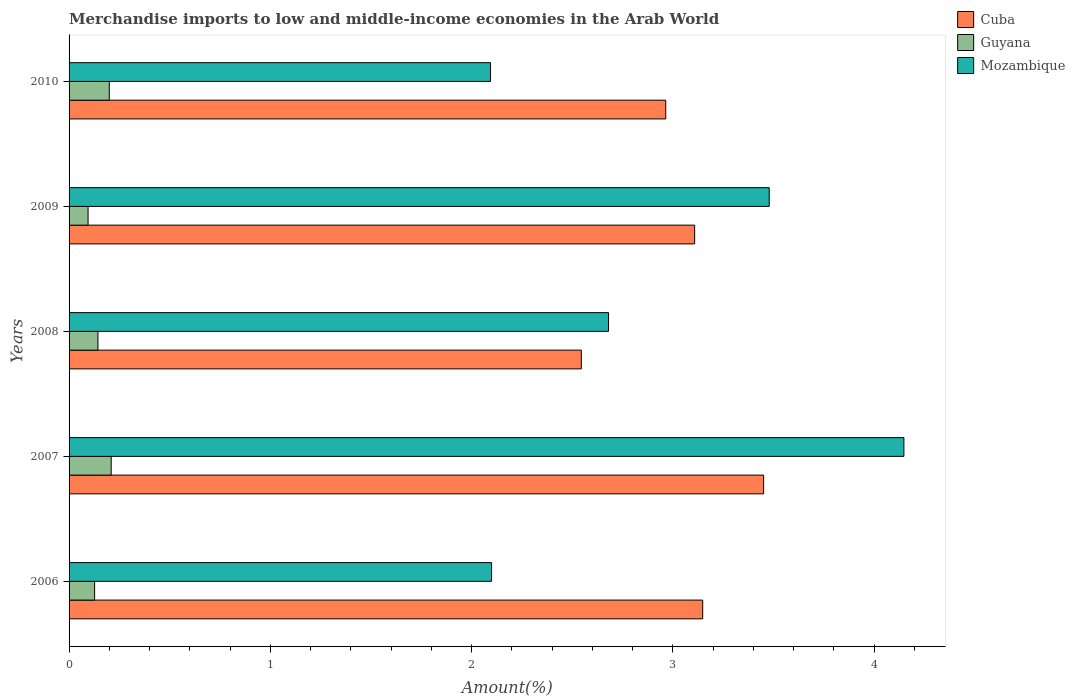How many groups of bars are there?
Provide a short and direct response. 5. Are the number of bars per tick equal to the number of legend labels?
Your response must be concise. Yes. In how many cases, is the number of bars for a given year not equal to the number of legend labels?
Provide a short and direct response. 0. What is the percentage of amount earned from merchandise imports in Cuba in 2009?
Give a very brief answer. 3.11. Across all years, what is the maximum percentage of amount earned from merchandise imports in Mozambique?
Your answer should be compact. 4.15. Across all years, what is the minimum percentage of amount earned from merchandise imports in Guyana?
Your response must be concise. 0.09. In which year was the percentage of amount earned from merchandise imports in Guyana maximum?
Your response must be concise. 2007. What is the total percentage of amount earned from merchandise imports in Cuba in the graph?
Your answer should be compact. 15.22. What is the difference between the percentage of amount earned from merchandise imports in Cuba in 2006 and that in 2008?
Your response must be concise. 0.6. What is the difference between the percentage of amount earned from merchandise imports in Guyana in 2008 and the percentage of amount earned from merchandise imports in Cuba in 2007?
Your answer should be compact. -3.31. What is the average percentage of amount earned from merchandise imports in Cuba per year?
Give a very brief answer. 3.04. In the year 2006, what is the difference between the percentage of amount earned from merchandise imports in Mozambique and percentage of amount earned from merchandise imports in Guyana?
Provide a short and direct response. 1.97. In how many years, is the percentage of amount earned from merchandise imports in Guyana greater than 2.6 %?
Offer a terse response. 0. What is the ratio of the percentage of amount earned from merchandise imports in Mozambique in 2009 to that in 2010?
Offer a terse response. 1.66. Is the percentage of amount earned from merchandise imports in Cuba in 2006 less than that in 2009?
Offer a very short reply. No. What is the difference between the highest and the second highest percentage of amount earned from merchandise imports in Guyana?
Keep it short and to the point. 0.01. What is the difference between the highest and the lowest percentage of amount earned from merchandise imports in Cuba?
Provide a short and direct response. 0.91. In how many years, is the percentage of amount earned from merchandise imports in Guyana greater than the average percentage of amount earned from merchandise imports in Guyana taken over all years?
Provide a succinct answer. 2. Is the sum of the percentage of amount earned from merchandise imports in Mozambique in 2007 and 2009 greater than the maximum percentage of amount earned from merchandise imports in Guyana across all years?
Your response must be concise. Yes. What does the 2nd bar from the top in 2007 represents?
Keep it short and to the point. Guyana. What does the 2nd bar from the bottom in 2010 represents?
Offer a very short reply. Guyana. How many bars are there?
Provide a succinct answer. 15. Are the values on the major ticks of X-axis written in scientific E-notation?
Provide a short and direct response. No. Does the graph contain grids?
Offer a terse response. No. Where does the legend appear in the graph?
Provide a succinct answer. Top right. How many legend labels are there?
Ensure brevity in your answer.  3. How are the legend labels stacked?
Provide a succinct answer. Vertical. What is the title of the graph?
Offer a very short reply. Merchandise imports to low and middle-income economies in the Arab World. What is the label or title of the X-axis?
Make the answer very short. Amount(%). What is the label or title of the Y-axis?
Offer a very short reply. Years. What is the Amount(%) in Cuba in 2006?
Offer a terse response. 3.15. What is the Amount(%) in Guyana in 2006?
Provide a succinct answer. 0.13. What is the Amount(%) of Mozambique in 2006?
Your answer should be compact. 2.1. What is the Amount(%) of Cuba in 2007?
Your response must be concise. 3.45. What is the Amount(%) of Guyana in 2007?
Offer a terse response. 0.21. What is the Amount(%) of Mozambique in 2007?
Offer a terse response. 4.15. What is the Amount(%) of Cuba in 2008?
Keep it short and to the point. 2.55. What is the Amount(%) of Guyana in 2008?
Provide a short and direct response. 0.14. What is the Amount(%) in Mozambique in 2008?
Your answer should be very brief. 2.68. What is the Amount(%) in Cuba in 2009?
Your answer should be compact. 3.11. What is the Amount(%) in Guyana in 2009?
Provide a short and direct response. 0.09. What is the Amount(%) in Mozambique in 2009?
Your answer should be compact. 3.48. What is the Amount(%) of Cuba in 2010?
Offer a terse response. 2.96. What is the Amount(%) in Guyana in 2010?
Ensure brevity in your answer.  0.2. What is the Amount(%) of Mozambique in 2010?
Provide a succinct answer. 2.09. Across all years, what is the maximum Amount(%) in Cuba?
Offer a very short reply. 3.45. Across all years, what is the maximum Amount(%) of Guyana?
Offer a terse response. 0.21. Across all years, what is the maximum Amount(%) in Mozambique?
Keep it short and to the point. 4.15. Across all years, what is the minimum Amount(%) of Cuba?
Give a very brief answer. 2.55. Across all years, what is the minimum Amount(%) in Guyana?
Ensure brevity in your answer.  0.09. Across all years, what is the minimum Amount(%) of Mozambique?
Keep it short and to the point. 2.09. What is the total Amount(%) of Cuba in the graph?
Keep it short and to the point. 15.22. What is the total Amount(%) of Guyana in the graph?
Make the answer very short. 0.77. What is the total Amount(%) of Mozambique in the graph?
Keep it short and to the point. 14.5. What is the difference between the Amount(%) of Cuba in 2006 and that in 2007?
Your response must be concise. -0.3. What is the difference between the Amount(%) of Guyana in 2006 and that in 2007?
Keep it short and to the point. -0.08. What is the difference between the Amount(%) of Mozambique in 2006 and that in 2007?
Ensure brevity in your answer.  -2.05. What is the difference between the Amount(%) in Cuba in 2006 and that in 2008?
Provide a short and direct response. 0.6. What is the difference between the Amount(%) of Guyana in 2006 and that in 2008?
Your response must be concise. -0.02. What is the difference between the Amount(%) in Mozambique in 2006 and that in 2008?
Give a very brief answer. -0.58. What is the difference between the Amount(%) in Cuba in 2006 and that in 2009?
Your response must be concise. 0.04. What is the difference between the Amount(%) of Guyana in 2006 and that in 2009?
Your answer should be very brief. 0.03. What is the difference between the Amount(%) of Mozambique in 2006 and that in 2009?
Offer a terse response. -1.38. What is the difference between the Amount(%) of Cuba in 2006 and that in 2010?
Keep it short and to the point. 0.18. What is the difference between the Amount(%) of Guyana in 2006 and that in 2010?
Offer a very short reply. -0.07. What is the difference between the Amount(%) in Mozambique in 2006 and that in 2010?
Your answer should be very brief. 0.01. What is the difference between the Amount(%) of Cuba in 2007 and that in 2008?
Offer a very short reply. 0.91. What is the difference between the Amount(%) of Guyana in 2007 and that in 2008?
Ensure brevity in your answer.  0.07. What is the difference between the Amount(%) in Mozambique in 2007 and that in 2008?
Give a very brief answer. 1.47. What is the difference between the Amount(%) in Cuba in 2007 and that in 2009?
Provide a short and direct response. 0.34. What is the difference between the Amount(%) of Guyana in 2007 and that in 2009?
Offer a terse response. 0.11. What is the difference between the Amount(%) in Mozambique in 2007 and that in 2009?
Offer a very short reply. 0.67. What is the difference between the Amount(%) of Cuba in 2007 and that in 2010?
Give a very brief answer. 0.49. What is the difference between the Amount(%) in Guyana in 2007 and that in 2010?
Give a very brief answer. 0.01. What is the difference between the Amount(%) of Mozambique in 2007 and that in 2010?
Make the answer very short. 2.05. What is the difference between the Amount(%) in Cuba in 2008 and that in 2009?
Your answer should be compact. -0.56. What is the difference between the Amount(%) in Guyana in 2008 and that in 2009?
Keep it short and to the point. 0.05. What is the difference between the Amount(%) of Mozambique in 2008 and that in 2009?
Provide a succinct answer. -0.8. What is the difference between the Amount(%) of Cuba in 2008 and that in 2010?
Make the answer very short. -0.42. What is the difference between the Amount(%) of Guyana in 2008 and that in 2010?
Ensure brevity in your answer.  -0.06. What is the difference between the Amount(%) in Mozambique in 2008 and that in 2010?
Give a very brief answer. 0.59. What is the difference between the Amount(%) of Cuba in 2009 and that in 2010?
Your answer should be very brief. 0.14. What is the difference between the Amount(%) in Guyana in 2009 and that in 2010?
Keep it short and to the point. -0.11. What is the difference between the Amount(%) of Mozambique in 2009 and that in 2010?
Keep it short and to the point. 1.38. What is the difference between the Amount(%) in Cuba in 2006 and the Amount(%) in Guyana in 2007?
Provide a succinct answer. 2.94. What is the difference between the Amount(%) in Cuba in 2006 and the Amount(%) in Mozambique in 2007?
Provide a succinct answer. -1. What is the difference between the Amount(%) of Guyana in 2006 and the Amount(%) of Mozambique in 2007?
Provide a succinct answer. -4.02. What is the difference between the Amount(%) of Cuba in 2006 and the Amount(%) of Guyana in 2008?
Your answer should be compact. 3.01. What is the difference between the Amount(%) in Cuba in 2006 and the Amount(%) in Mozambique in 2008?
Provide a short and direct response. 0.47. What is the difference between the Amount(%) in Guyana in 2006 and the Amount(%) in Mozambique in 2008?
Make the answer very short. -2.55. What is the difference between the Amount(%) in Cuba in 2006 and the Amount(%) in Guyana in 2009?
Make the answer very short. 3.05. What is the difference between the Amount(%) in Cuba in 2006 and the Amount(%) in Mozambique in 2009?
Keep it short and to the point. -0.33. What is the difference between the Amount(%) in Guyana in 2006 and the Amount(%) in Mozambique in 2009?
Your answer should be compact. -3.35. What is the difference between the Amount(%) in Cuba in 2006 and the Amount(%) in Guyana in 2010?
Offer a very short reply. 2.95. What is the difference between the Amount(%) of Cuba in 2006 and the Amount(%) of Mozambique in 2010?
Offer a terse response. 1.05. What is the difference between the Amount(%) of Guyana in 2006 and the Amount(%) of Mozambique in 2010?
Offer a terse response. -1.97. What is the difference between the Amount(%) of Cuba in 2007 and the Amount(%) of Guyana in 2008?
Your answer should be very brief. 3.31. What is the difference between the Amount(%) in Cuba in 2007 and the Amount(%) in Mozambique in 2008?
Offer a terse response. 0.77. What is the difference between the Amount(%) in Guyana in 2007 and the Amount(%) in Mozambique in 2008?
Offer a very short reply. -2.47. What is the difference between the Amount(%) of Cuba in 2007 and the Amount(%) of Guyana in 2009?
Your response must be concise. 3.36. What is the difference between the Amount(%) in Cuba in 2007 and the Amount(%) in Mozambique in 2009?
Ensure brevity in your answer.  -0.03. What is the difference between the Amount(%) of Guyana in 2007 and the Amount(%) of Mozambique in 2009?
Your response must be concise. -3.27. What is the difference between the Amount(%) in Cuba in 2007 and the Amount(%) in Guyana in 2010?
Give a very brief answer. 3.25. What is the difference between the Amount(%) in Cuba in 2007 and the Amount(%) in Mozambique in 2010?
Provide a short and direct response. 1.36. What is the difference between the Amount(%) in Guyana in 2007 and the Amount(%) in Mozambique in 2010?
Your answer should be very brief. -1.89. What is the difference between the Amount(%) of Cuba in 2008 and the Amount(%) of Guyana in 2009?
Your answer should be very brief. 2.45. What is the difference between the Amount(%) in Cuba in 2008 and the Amount(%) in Mozambique in 2009?
Your answer should be very brief. -0.93. What is the difference between the Amount(%) in Guyana in 2008 and the Amount(%) in Mozambique in 2009?
Your answer should be compact. -3.34. What is the difference between the Amount(%) in Cuba in 2008 and the Amount(%) in Guyana in 2010?
Ensure brevity in your answer.  2.35. What is the difference between the Amount(%) in Cuba in 2008 and the Amount(%) in Mozambique in 2010?
Give a very brief answer. 0.45. What is the difference between the Amount(%) in Guyana in 2008 and the Amount(%) in Mozambique in 2010?
Your answer should be very brief. -1.95. What is the difference between the Amount(%) in Cuba in 2009 and the Amount(%) in Guyana in 2010?
Give a very brief answer. 2.91. What is the difference between the Amount(%) in Cuba in 2009 and the Amount(%) in Mozambique in 2010?
Keep it short and to the point. 1.01. What is the difference between the Amount(%) of Guyana in 2009 and the Amount(%) of Mozambique in 2010?
Your answer should be compact. -2. What is the average Amount(%) in Cuba per year?
Keep it short and to the point. 3.04. What is the average Amount(%) in Guyana per year?
Give a very brief answer. 0.15. What is the average Amount(%) of Mozambique per year?
Ensure brevity in your answer.  2.9. In the year 2006, what is the difference between the Amount(%) of Cuba and Amount(%) of Guyana?
Give a very brief answer. 3.02. In the year 2006, what is the difference between the Amount(%) in Cuba and Amount(%) in Mozambique?
Offer a very short reply. 1.05. In the year 2006, what is the difference between the Amount(%) in Guyana and Amount(%) in Mozambique?
Provide a succinct answer. -1.97. In the year 2007, what is the difference between the Amount(%) of Cuba and Amount(%) of Guyana?
Your answer should be very brief. 3.24. In the year 2007, what is the difference between the Amount(%) of Cuba and Amount(%) of Mozambique?
Make the answer very short. -0.7. In the year 2007, what is the difference between the Amount(%) in Guyana and Amount(%) in Mozambique?
Your answer should be compact. -3.94. In the year 2008, what is the difference between the Amount(%) of Cuba and Amount(%) of Guyana?
Provide a short and direct response. 2.4. In the year 2008, what is the difference between the Amount(%) of Cuba and Amount(%) of Mozambique?
Provide a succinct answer. -0.14. In the year 2008, what is the difference between the Amount(%) in Guyana and Amount(%) in Mozambique?
Give a very brief answer. -2.54. In the year 2009, what is the difference between the Amount(%) of Cuba and Amount(%) of Guyana?
Offer a very short reply. 3.01. In the year 2009, what is the difference between the Amount(%) of Cuba and Amount(%) of Mozambique?
Give a very brief answer. -0.37. In the year 2009, what is the difference between the Amount(%) in Guyana and Amount(%) in Mozambique?
Keep it short and to the point. -3.38. In the year 2010, what is the difference between the Amount(%) of Cuba and Amount(%) of Guyana?
Keep it short and to the point. 2.77. In the year 2010, what is the difference between the Amount(%) in Cuba and Amount(%) in Mozambique?
Ensure brevity in your answer.  0.87. In the year 2010, what is the difference between the Amount(%) of Guyana and Amount(%) of Mozambique?
Keep it short and to the point. -1.89. What is the ratio of the Amount(%) in Cuba in 2006 to that in 2007?
Your response must be concise. 0.91. What is the ratio of the Amount(%) of Guyana in 2006 to that in 2007?
Give a very brief answer. 0.61. What is the ratio of the Amount(%) of Mozambique in 2006 to that in 2007?
Offer a terse response. 0.51. What is the ratio of the Amount(%) in Cuba in 2006 to that in 2008?
Ensure brevity in your answer.  1.24. What is the ratio of the Amount(%) in Guyana in 2006 to that in 2008?
Your response must be concise. 0.88. What is the ratio of the Amount(%) in Mozambique in 2006 to that in 2008?
Your answer should be compact. 0.78. What is the ratio of the Amount(%) in Cuba in 2006 to that in 2009?
Offer a terse response. 1.01. What is the ratio of the Amount(%) of Guyana in 2006 to that in 2009?
Make the answer very short. 1.34. What is the ratio of the Amount(%) of Mozambique in 2006 to that in 2009?
Keep it short and to the point. 0.6. What is the ratio of the Amount(%) in Cuba in 2006 to that in 2010?
Your response must be concise. 1.06. What is the ratio of the Amount(%) of Guyana in 2006 to that in 2010?
Your response must be concise. 0.64. What is the ratio of the Amount(%) of Cuba in 2007 to that in 2008?
Your answer should be very brief. 1.36. What is the ratio of the Amount(%) of Guyana in 2007 to that in 2008?
Your answer should be compact. 1.46. What is the ratio of the Amount(%) of Mozambique in 2007 to that in 2008?
Offer a terse response. 1.55. What is the ratio of the Amount(%) in Cuba in 2007 to that in 2009?
Ensure brevity in your answer.  1.11. What is the ratio of the Amount(%) of Guyana in 2007 to that in 2009?
Offer a terse response. 2.22. What is the ratio of the Amount(%) in Mozambique in 2007 to that in 2009?
Make the answer very short. 1.19. What is the ratio of the Amount(%) of Cuba in 2007 to that in 2010?
Provide a short and direct response. 1.16. What is the ratio of the Amount(%) in Guyana in 2007 to that in 2010?
Your answer should be compact. 1.05. What is the ratio of the Amount(%) in Mozambique in 2007 to that in 2010?
Provide a succinct answer. 1.98. What is the ratio of the Amount(%) in Cuba in 2008 to that in 2009?
Provide a succinct answer. 0.82. What is the ratio of the Amount(%) of Guyana in 2008 to that in 2009?
Give a very brief answer. 1.52. What is the ratio of the Amount(%) in Mozambique in 2008 to that in 2009?
Make the answer very short. 0.77. What is the ratio of the Amount(%) of Cuba in 2008 to that in 2010?
Your answer should be compact. 0.86. What is the ratio of the Amount(%) in Guyana in 2008 to that in 2010?
Your answer should be very brief. 0.72. What is the ratio of the Amount(%) in Mozambique in 2008 to that in 2010?
Ensure brevity in your answer.  1.28. What is the ratio of the Amount(%) of Cuba in 2009 to that in 2010?
Offer a terse response. 1.05. What is the ratio of the Amount(%) in Guyana in 2009 to that in 2010?
Offer a very short reply. 0.47. What is the ratio of the Amount(%) in Mozambique in 2009 to that in 2010?
Offer a very short reply. 1.66. What is the difference between the highest and the second highest Amount(%) of Cuba?
Give a very brief answer. 0.3. What is the difference between the highest and the second highest Amount(%) in Guyana?
Provide a short and direct response. 0.01. What is the difference between the highest and the second highest Amount(%) of Mozambique?
Ensure brevity in your answer.  0.67. What is the difference between the highest and the lowest Amount(%) of Cuba?
Your answer should be very brief. 0.91. What is the difference between the highest and the lowest Amount(%) in Guyana?
Make the answer very short. 0.11. What is the difference between the highest and the lowest Amount(%) of Mozambique?
Your answer should be very brief. 2.05. 